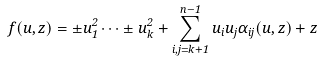<formula> <loc_0><loc_0><loc_500><loc_500>f ( u , z ) = \pm u ^ { 2 } _ { 1 } \cdots \pm u ^ { 2 } _ { k } + \sum _ { i , j = k + 1 } ^ { n - 1 } u _ { i } u _ { j } \alpha _ { i j } ( u , z ) + z</formula> 